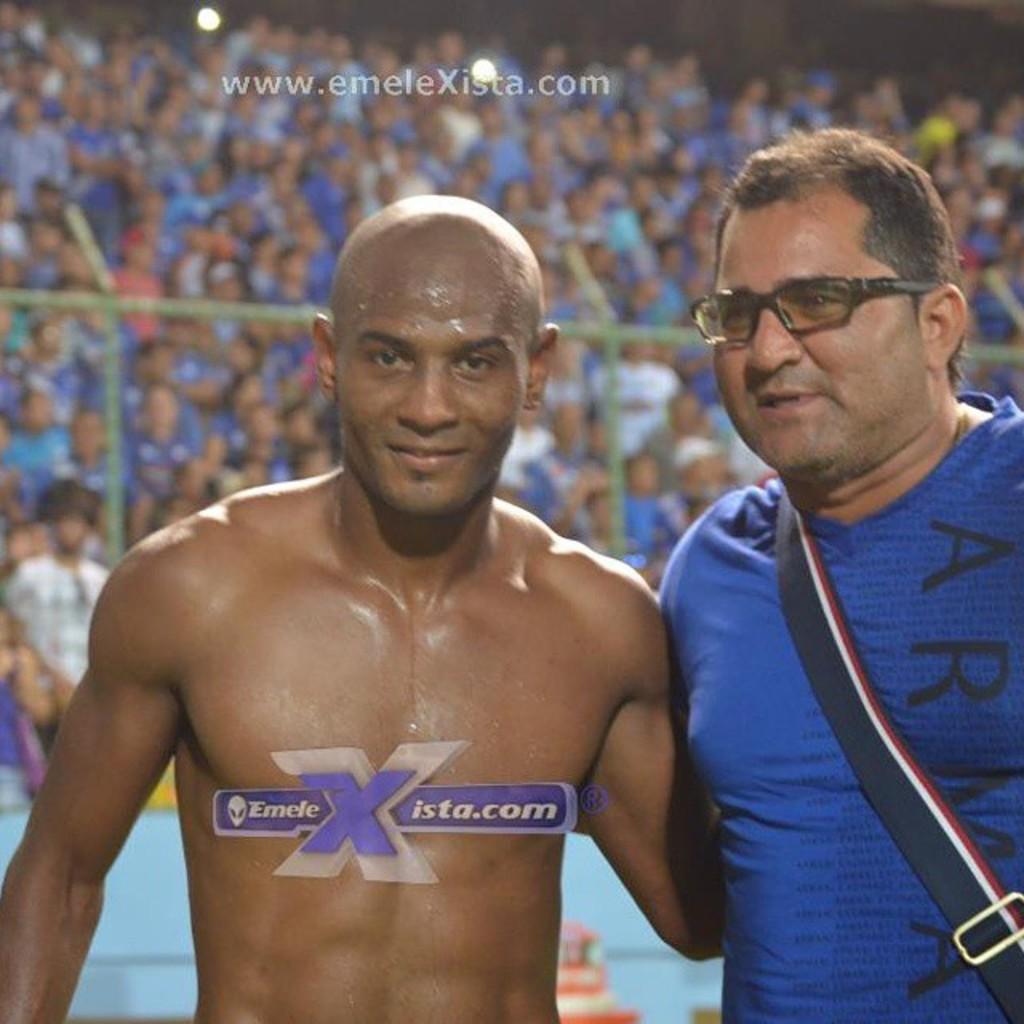<image>
Share a concise interpretation of the image provided. Man wearing a blue shirt that says ARMA next to another man that is shirtless. 